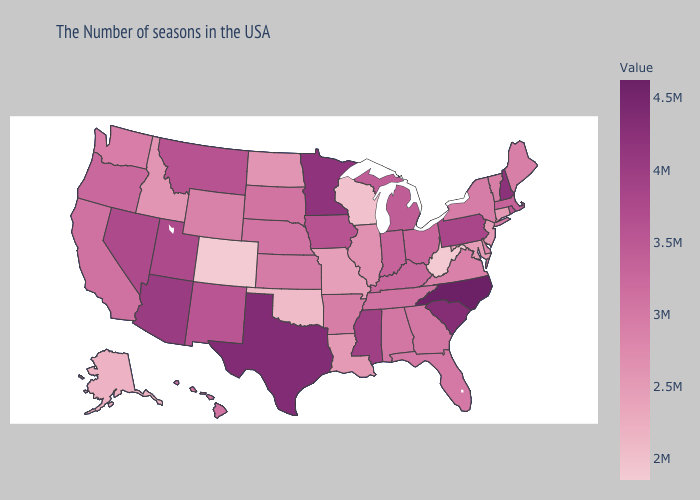Does Massachusetts have the lowest value in the USA?
Give a very brief answer. No. Does North Carolina have the highest value in the South?
Keep it brief. Yes. Does Minnesota have the highest value in the MidWest?
Quick response, please. Yes. Does Arkansas have the lowest value in the USA?
Keep it brief. No. Does Wisconsin have the lowest value in the MidWest?
Concise answer only. Yes. Is the legend a continuous bar?
Quick response, please. Yes. Does the map have missing data?
Short answer required. No. Does Colorado have the lowest value in the USA?
Concise answer only. Yes. Which states have the highest value in the USA?
Answer briefly. North Carolina. Among the states that border Nevada , which have the lowest value?
Be succinct. Idaho. 